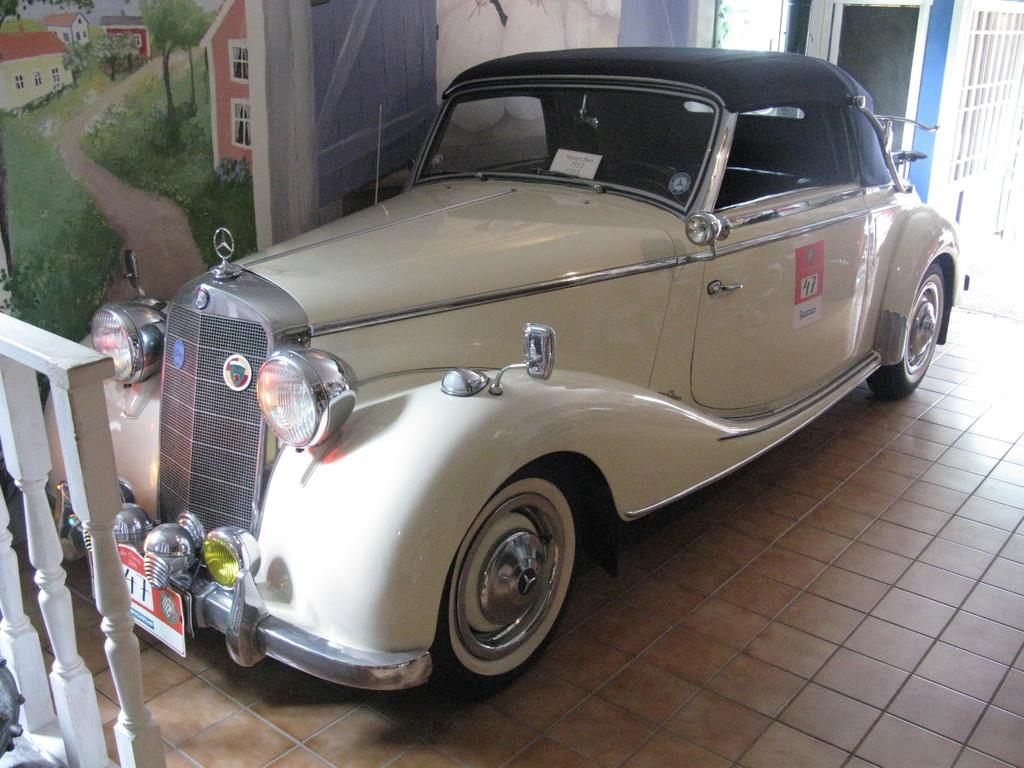What is the main subject in the center of the image? There is a car in the center of the image. What can be seen on the left side of the image? There is a fence on the left side of the image. What is visible in the background of the image? There is a wall painting in the background of the image. What is the surface that the car is standing on? There is a floor visible at the bottom of the image. How many balls are bouncing off the car in the image? There are no balls present in the image, so it is not possible to determine how many might be bouncing off the car. 